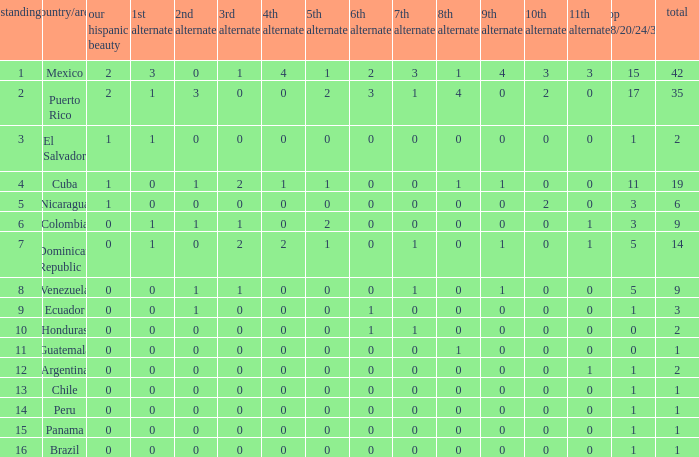What is the 9th runner-up with a top 18/20/24/30 greater than 17 and a 5th runner-up of 2? None. 